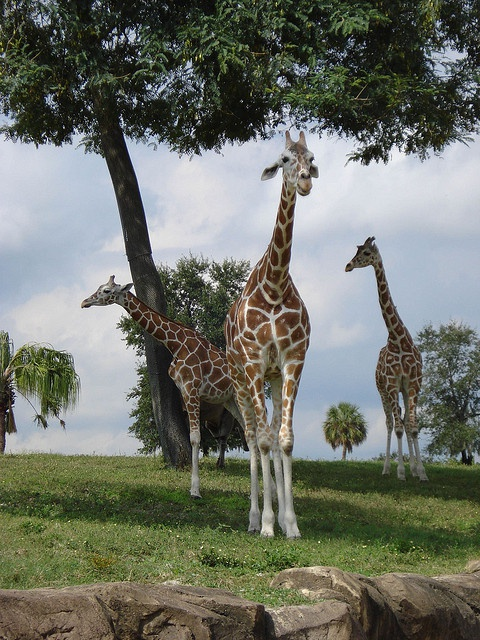Describe the objects in this image and their specific colors. I can see giraffe in black, gray, darkgray, and maroon tones, giraffe in black, gray, maroon, and darkgray tones, and giraffe in black and gray tones in this image. 